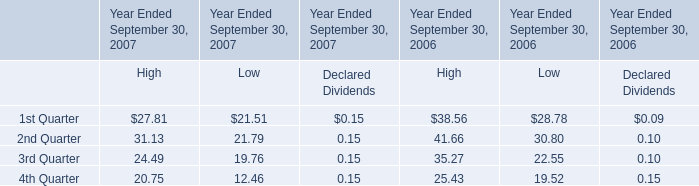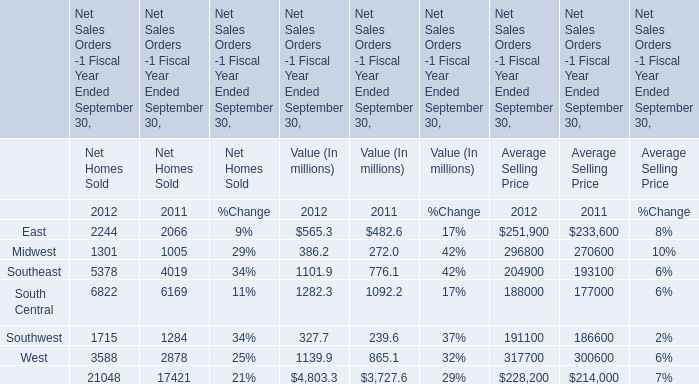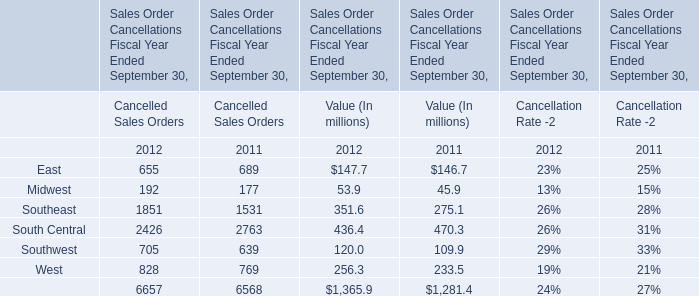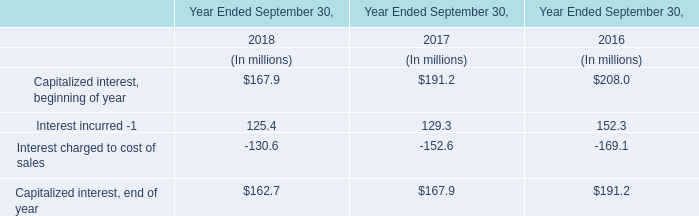How many kinds of Cancelled Sales Orders are greater than 1000 in 2012? 
Answer: 2. 